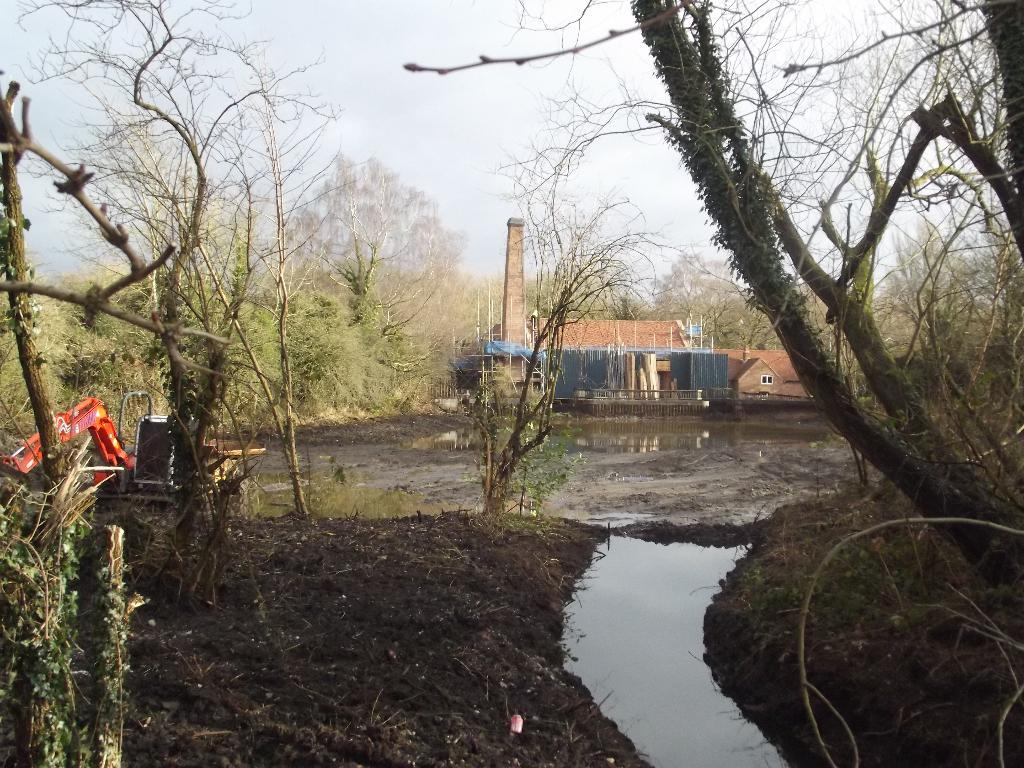What is the primary element visible in the image? There is water in the image. What type of vegetation can be seen on the ground? There are trees and plants on the ground. What structure is located in the middle of the image? There is a house in the middle of the image. What is visible in the background of the image? The sky is visible in the background of the image. Can you see any ants carrying a bone in the image? There are no ants or bones present in the image. 